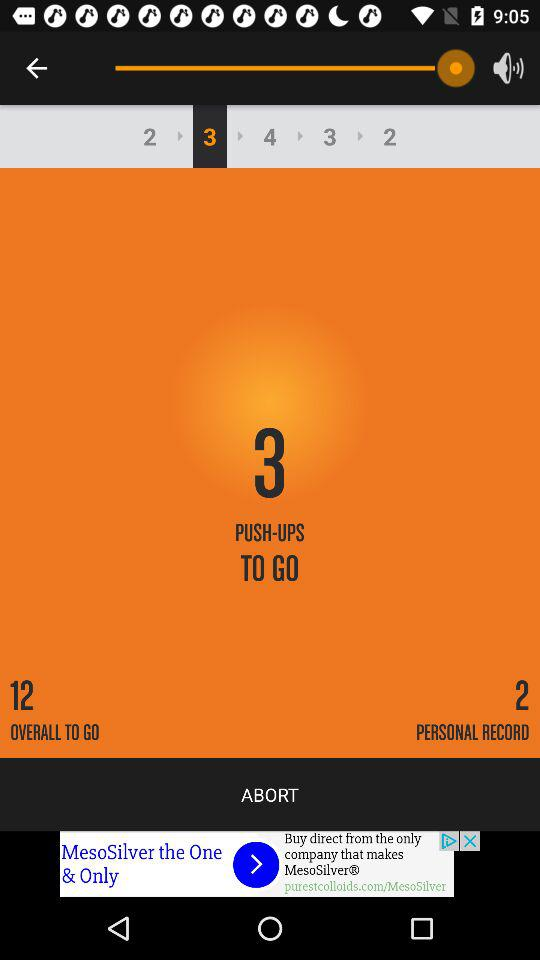How many push-ups are there to complete the set? There are three push-ups to complete the set. 